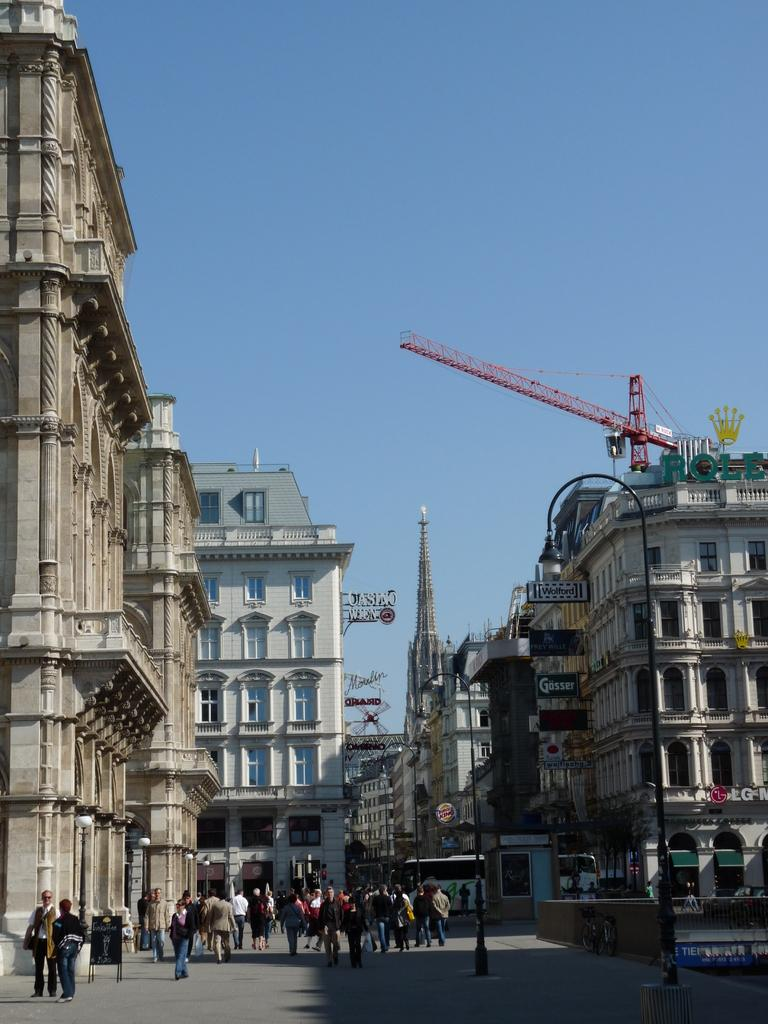What can be seen on both sides of the image? There are buildings on both the right and left sides of the image. What structures are present at the bottom of the image? Light poles are visible at the bottom of the image. What is happening at the bottom of the image? There are persons on the road at the bottom of the image. What is visible in the background of the image? The sky is visible in the background of the image. What type of gold is being used to pave the road in the image? There is no gold present on the road in the image; it is a regular road with persons walking on it. What emotion can be seen on the faces of the persons in the image? The image does not show the faces of the persons, so it is not possible to determine their emotions. 